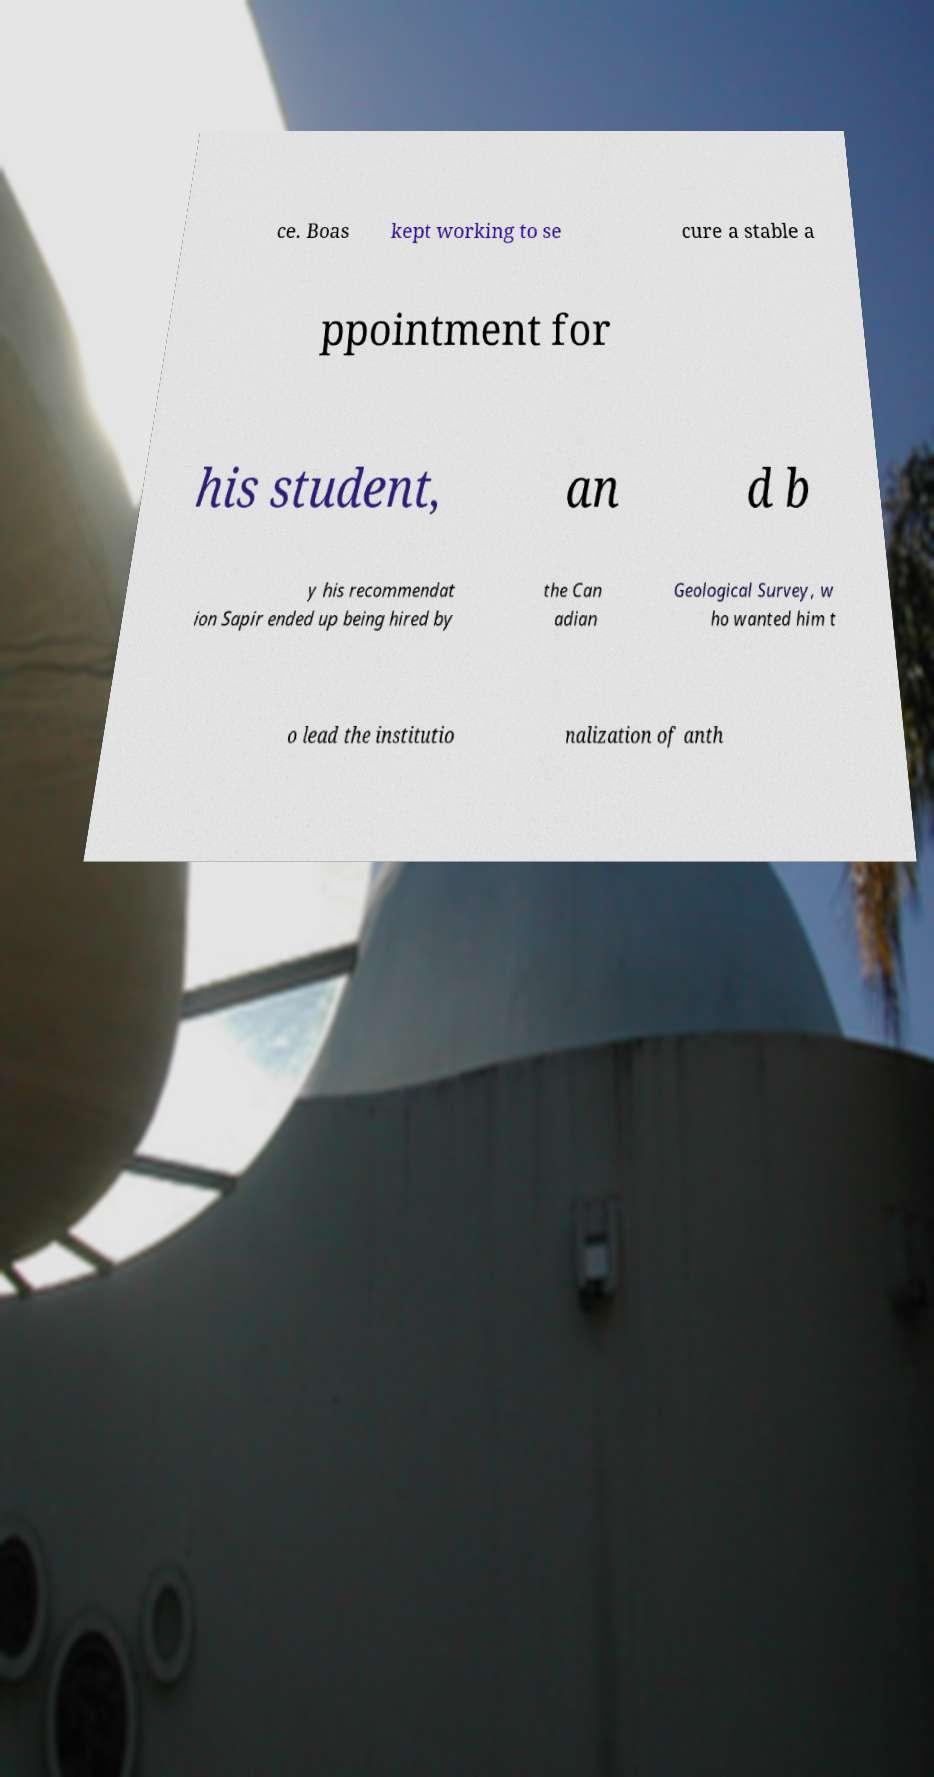Can you read and provide the text displayed in the image?This photo seems to have some interesting text. Can you extract and type it out for me? ce. Boas kept working to se cure a stable a ppointment for his student, an d b y his recommendat ion Sapir ended up being hired by the Can adian Geological Survey, w ho wanted him t o lead the institutio nalization of anth 